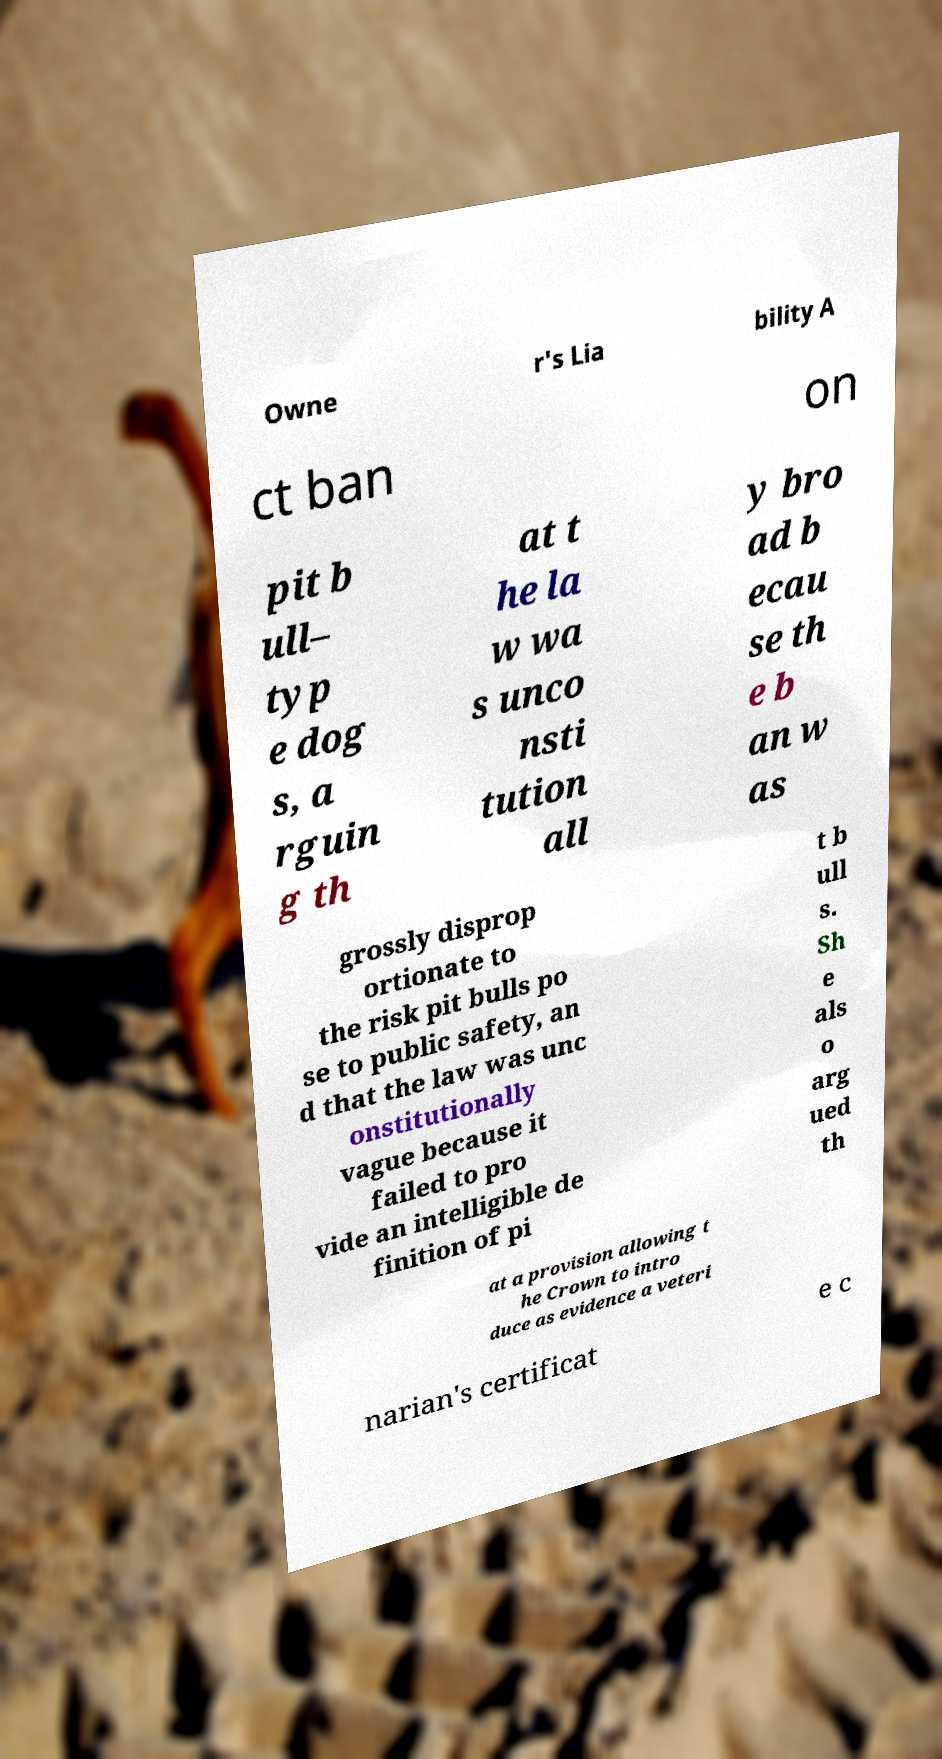Could you assist in decoding the text presented in this image and type it out clearly? Owne r's Lia bility A ct ban on pit b ull– typ e dog s, a rguin g th at t he la w wa s unco nsti tution all y bro ad b ecau se th e b an w as grossly disprop ortionate to the risk pit bulls po se to public safety, an d that the law was unc onstitutionally vague because it failed to pro vide an intelligible de finition of pi t b ull s. Sh e als o arg ued th at a provision allowing t he Crown to intro duce as evidence a veteri narian's certificat e c 